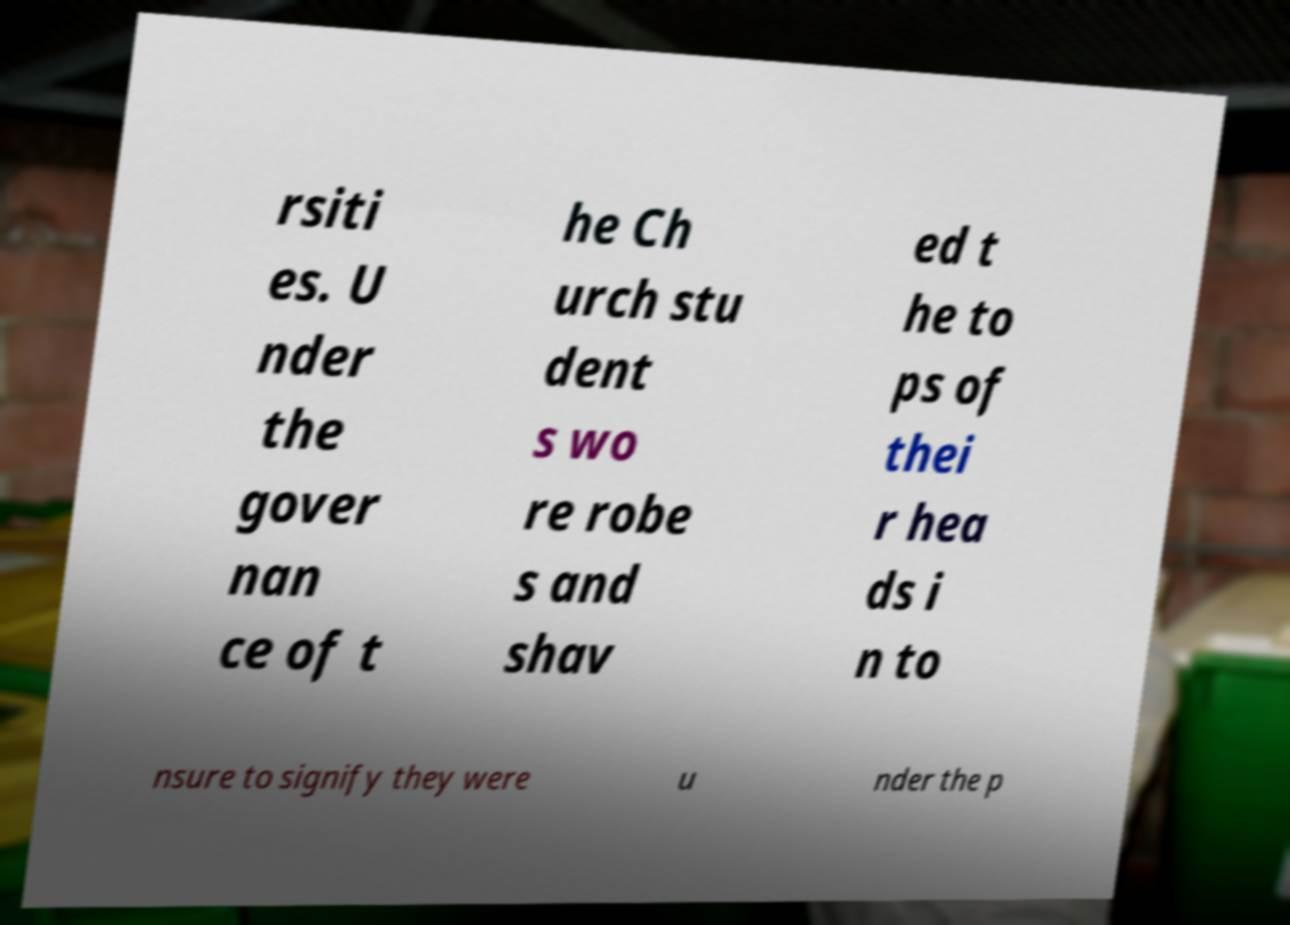For documentation purposes, I need the text within this image transcribed. Could you provide that? rsiti es. U nder the gover nan ce of t he Ch urch stu dent s wo re robe s and shav ed t he to ps of thei r hea ds i n to nsure to signify they were u nder the p 